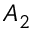Convert formula to latex. <formula><loc_0><loc_0><loc_500><loc_500>A _ { 2 }</formula> 